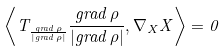Convert formula to latex. <formula><loc_0><loc_0><loc_500><loc_500>\left \langle T _ { \frac { g r a d \, \rho } { \left | g r a d \, \rho \right | } } \frac { g r a d \, \rho } { \left | g r a d \, \rho \right | } , \nabla _ { X } X \right \rangle = 0</formula> 